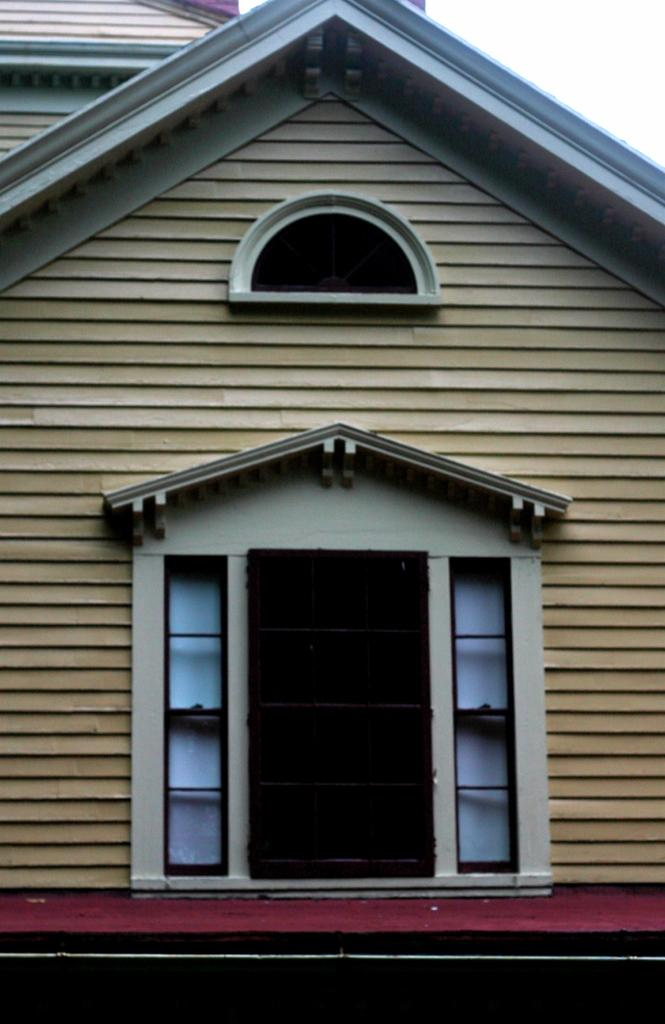What type of structure is visible in the picture? There is a house in the picture. Can you describe a specific feature of the house? There is a door in the house. What architectural element is present above the door? There is an arch above the door. What type of list can be seen hanging on the wall inside the house? There is no list visible in the image, as it only shows the exterior of the house with a door and an arch above it. 